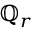Convert formula to latex. <formula><loc_0><loc_0><loc_500><loc_500>\mathbb { Q } _ { r }</formula> 